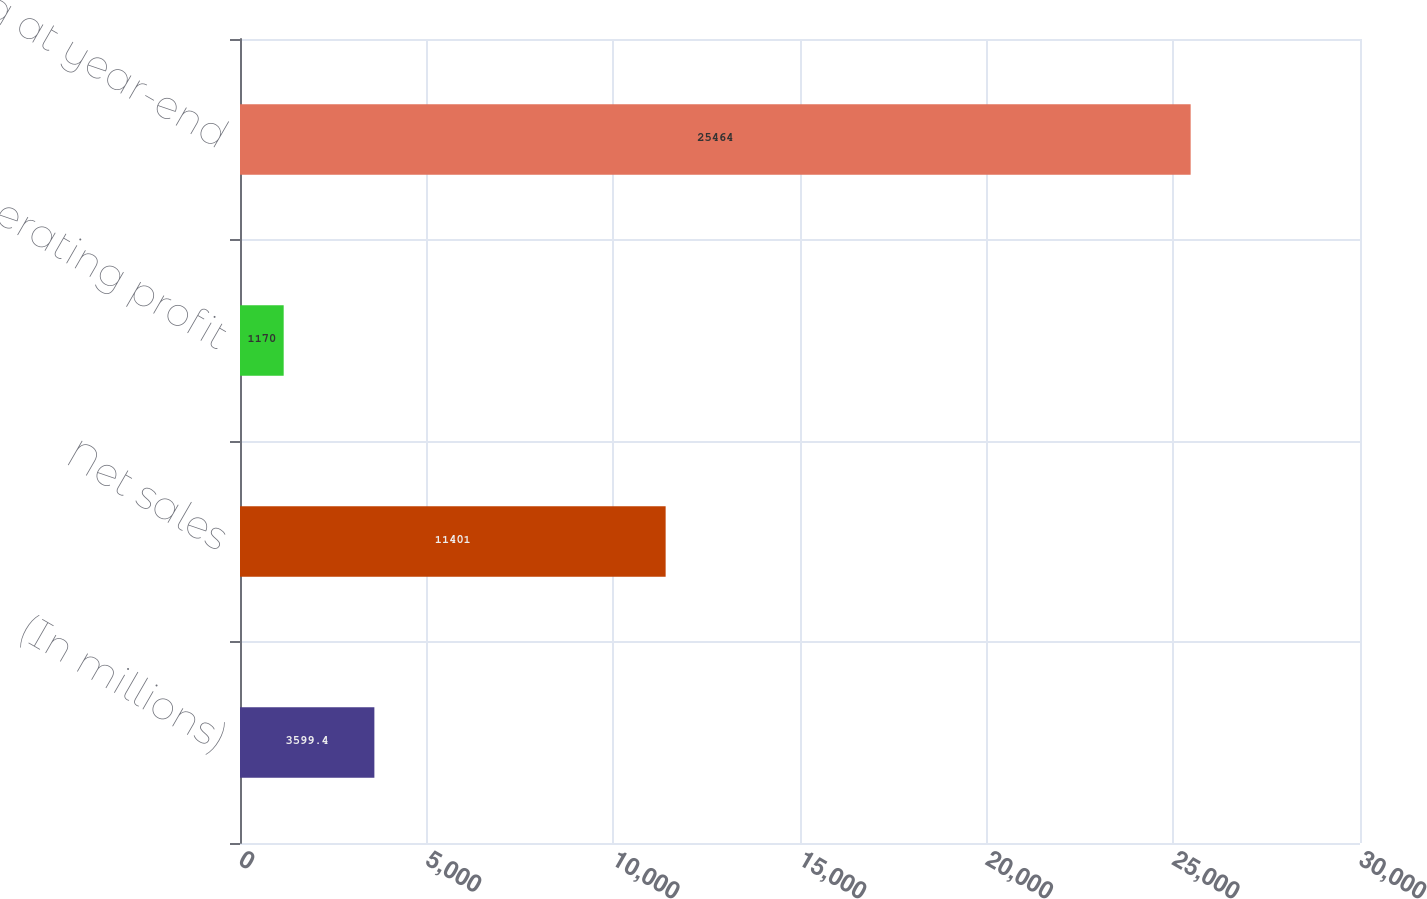<chart> <loc_0><loc_0><loc_500><loc_500><bar_chart><fcel>(In millions)<fcel>Net sales<fcel>Operating profit<fcel>Backlog at year-end<nl><fcel>3599.4<fcel>11401<fcel>1170<fcel>25464<nl></chart> 